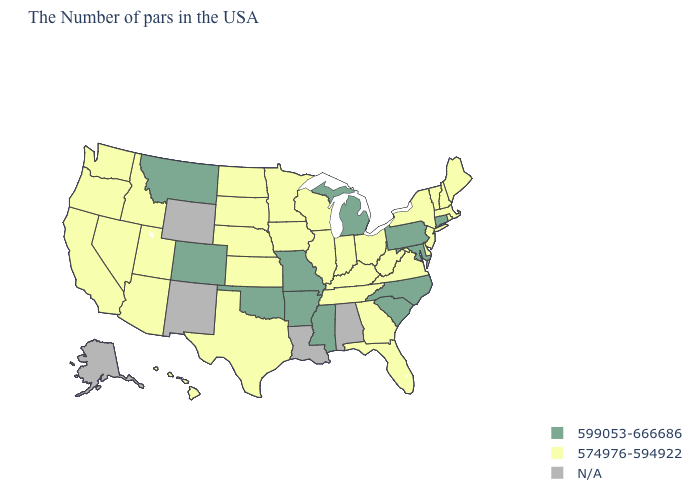What is the lowest value in the USA?
Short answer required. 574976-594922. Name the states that have a value in the range 574976-594922?
Quick response, please. Maine, Massachusetts, Rhode Island, New Hampshire, Vermont, New York, New Jersey, Delaware, Virginia, West Virginia, Ohio, Florida, Georgia, Kentucky, Indiana, Tennessee, Wisconsin, Illinois, Minnesota, Iowa, Kansas, Nebraska, Texas, South Dakota, North Dakota, Utah, Arizona, Idaho, Nevada, California, Washington, Oregon, Hawaii. What is the value of Maine?
Concise answer only. 574976-594922. Does the first symbol in the legend represent the smallest category?
Keep it brief. No. What is the lowest value in the USA?
Concise answer only. 574976-594922. Which states have the highest value in the USA?
Concise answer only. Connecticut, Maryland, Pennsylvania, North Carolina, South Carolina, Michigan, Mississippi, Missouri, Arkansas, Oklahoma, Colorado, Montana. What is the lowest value in states that border Idaho?
Write a very short answer. 574976-594922. Among the states that border Montana , which have the highest value?
Quick response, please. South Dakota, North Dakota, Idaho. What is the highest value in the MidWest ?
Quick response, please. 599053-666686. What is the value of Minnesota?
Give a very brief answer. 574976-594922. What is the value of Mississippi?
Keep it brief. 599053-666686. What is the highest value in states that border New Mexico?
Give a very brief answer. 599053-666686. 